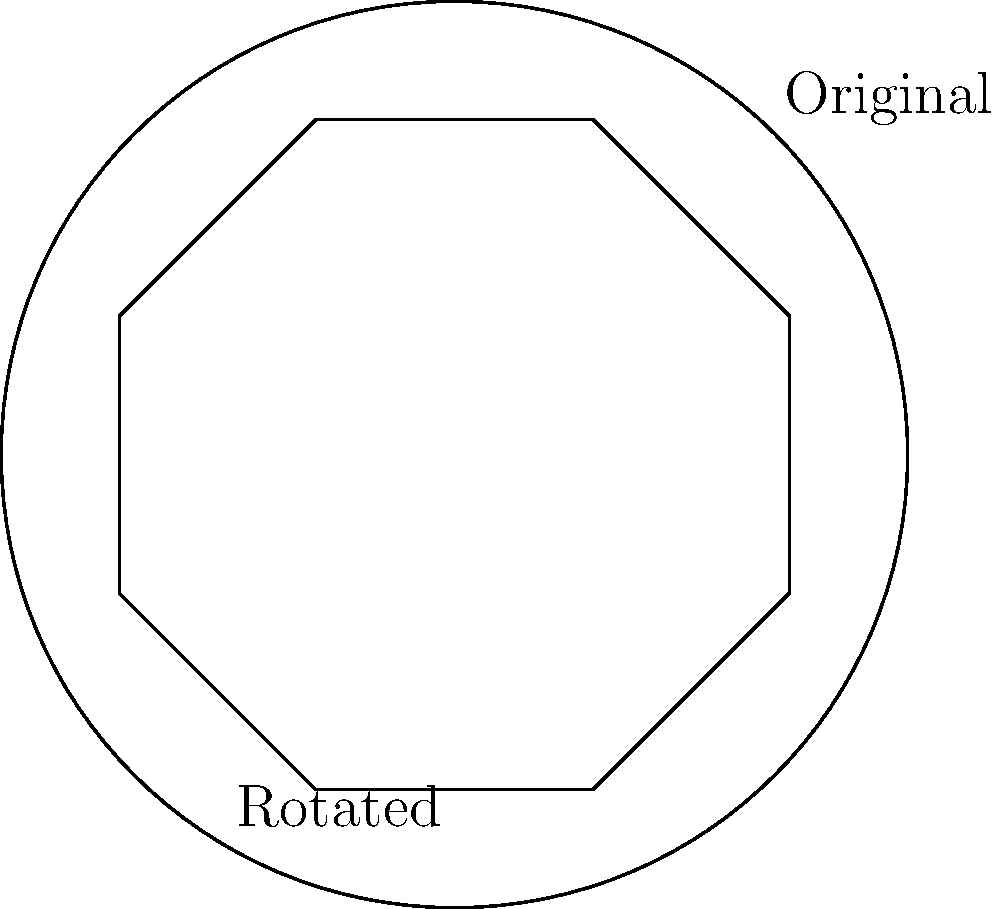As a restaurant owner looking to refresh your table settings, you decide to rotate the octagonal design on your plates. If the original design is centered on the plate and rotated $45°$ clockwise, how many times would you need to repeat this rotation to return the design to its original position? To solve this problem, let's follow these steps:

1. Recognize that the plate design is an octagon, which has 8 sides and 8-fold rotational symmetry.

2. Understand that a full rotation is $360°$.

3. Calculate how many $45°$ rotations are needed for a full $360°$ rotation:
   $\frac{360°}{45°} = 8$

4. Since the octagon has 8-fold symmetry, and it takes 8 rotations of $45°$ to complete a full circle, the design will return to its original position after 8 rotations.

5. Verify: $8 \times 45° = 360°$, which is a full rotation and brings the design back to its starting position.
Answer: 8 rotations 